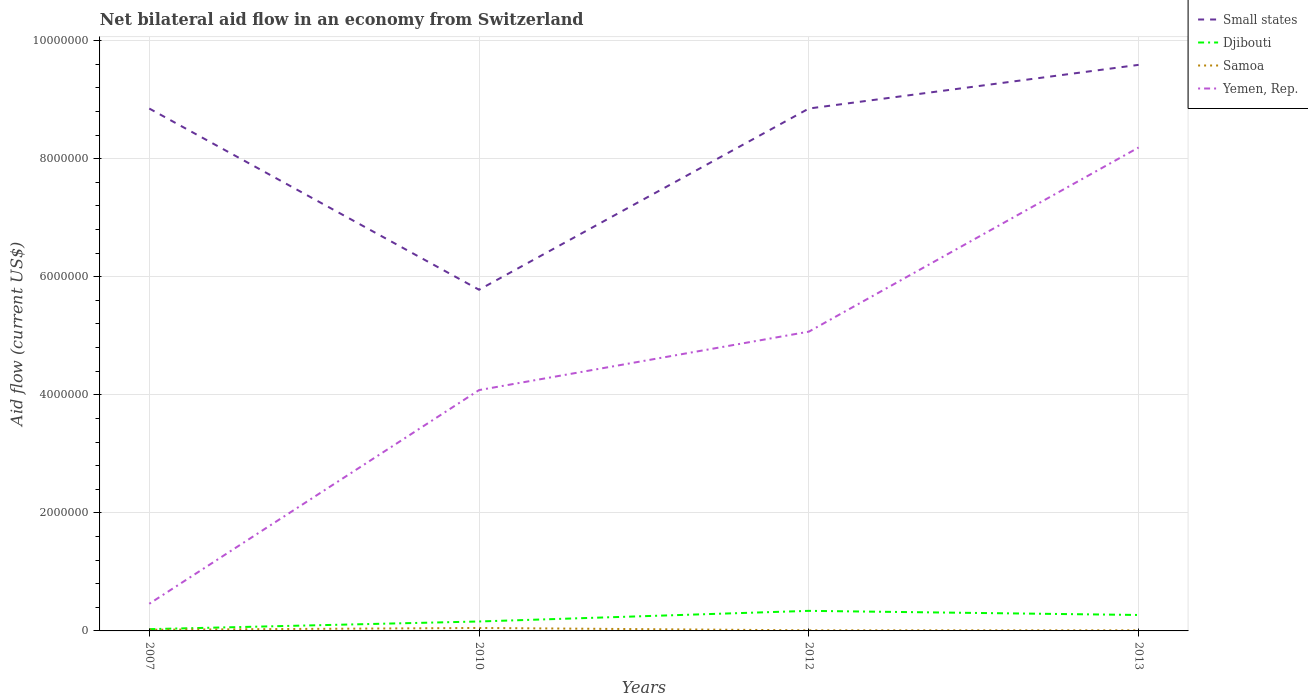How many different coloured lines are there?
Your response must be concise. 4. Is the number of lines equal to the number of legend labels?
Offer a very short reply. Yes. Across all years, what is the maximum net bilateral aid flow in Samoa?
Make the answer very short. 10000. What is the total net bilateral aid flow in Yemen, Rep. in the graph?
Provide a short and direct response. -9.90e+05. What is the difference between the highest and the second highest net bilateral aid flow in Samoa?
Offer a very short reply. 4.00e+04. Is the net bilateral aid flow in Samoa strictly greater than the net bilateral aid flow in Yemen, Rep. over the years?
Offer a terse response. Yes. How many lines are there?
Your answer should be compact. 4. How many years are there in the graph?
Provide a short and direct response. 4. Are the values on the major ticks of Y-axis written in scientific E-notation?
Offer a terse response. No. Does the graph contain grids?
Provide a succinct answer. Yes. Where does the legend appear in the graph?
Give a very brief answer. Top right. What is the title of the graph?
Your response must be concise. Net bilateral aid flow in an economy from Switzerland. What is the label or title of the X-axis?
Keep it short and to the point. Years. What is the Aid flow (current US$) in Small states in 2007?
Offer a very short reply. 8.85e+06. What is the Aid flow (current US$) in Samoa in 2007?
Your response must be concise. 2.00e+04. What is the Aid flow (current US$) of Small states in 2010?
Your response must be concise. 5.78e+06. What is the Aid flow (current US$) of Samoa in 2010?
Offer a terse response. 5.00e+04. What is the Aid flow (current US$) of Yemen, Rep. in 2010?
Provide a short and direct response. 4.08e+06. What is the Aid flow (current US$) in Small states in 2012?
Give a very brief answer. 8.85e+06. What is the Aid flow (current US$) of Djibouti in 2012?
Offer a terse response. 3.40e+05. What is the Aid flow (current US$) of Yemen, Rep. in 2012?
Keep it short and to the point. 5.07e+06. What is the Aid flow (current US$) in Small states in 2013?
Make the answer very short. 9.59e+06. What is the Aid flow (current US$) of Samoa in 2013?
Your answer should be very brief. 10000. What is the Aid flow (current US$) in Yemen, Rep. in 2013?
Keep it short and to the point. 8.19e+06. Across all years, what is the maximum Aid flow (current US$) of Small states?
Ensure brevity in your answer.  9.59e+06. Across all years, what is the maximum Aid flow (current US$) in Samoa?
Provide a short and direct response. 5.00e+04. Across all years, what is the maximum Aid flow (current US$) of Yemen, Rep.?
Make the answer very short. 8.19e+06. Across all years, what is the minimum Aid flow (current US$) in Small states?
Give a very brief answer. 5.78e+06. Across all years, what is the minimum Aid flow (current US$) of Samoa?
Offer a very short reply. 10000. What is the total Aid flow (current US$) in Small states in the graph?
Your answer should be compact. 3.31e+07. What is the total Aid flow (current US$) in Djibouti in the graph?
Your response must be concise. 8.00e+05. What is the total Aid flow (current US$) in Samoa in the graph?
Make the answer very short. 9.00e+04. What is the total Aid flow (current US$) of Yemen, Rep. in the graph?
Ensure brevity in your answer.  1.78e+07. What is the difference between the Aid flow (current US$) in Small states in 2007 and that in 2010?
Offer a terse response. 3.07e+06. What is the difference between the Aid flow (current US$) of Samoa in 2007 and that in 2010?
Ensure brevity in your answer.  -3.00e+04. What is the difference between the Aid flow (current US$) in Yemen, Rep. in 2007 and that in 2010?
Provide a succinct answer. -3.62e+06. What is the difference between the Aid flow (current US$) of Djibouti in 2007 and that in 2012?
Offer a very short reply. -3.10e+05. What is the difference between the Aid flow (current US$) of Samoa in 2007 and that in 2012?
Give a very brief answer. 10000. What is the difference between the Aid flow (current US$) in Yemen, Rep. in 2007 and that in 2012?
Keep it short and to the point. -4.61e+06. What is the difference between the Aid flow (current US$) in Small states in 2007 and that in 2013?
Make the answer very short. -7.40e+05. What is the difference between the Aid flow (current US$) of Djibouti in 2007 and that in 2013?
Keep it short and to the point. -2.40e+05. What is the difference between the Aid flow (current US$) of Samoa in 2007 and that in 2013?
Ensure brevity in your answer.  10000. What is the difference between the Aid flow (current US$) in Yemen, Rep. in 2007 and that in 2013?
Provide a short and direct response. -7.73e+06. What is the difference between the Aid flow (current US$) in Small states in 2010 and that in 2012?
Give a very brief answer. -3.07e+06. What is the difference between the Aid flow (current US$) in Djibouti in 2010 and that in 2012?
Your response must be concise. -1.80e+05. What is the difference between the Aid flow (current US$) of Yemen, Rep. in 2010 and that in 2012?
Make the answer very short. -9.90e+05. What is the difference between the Aid flow (current US$) in Small states in 2010 and that in 2013?
Your response must be concise. -3.81e+06. What is the difference between the Aid flow (current US$) of Yemen, Rep. in 2010 and that in 2013?
Ensure brevity in your answer.  -4.11e+06. What is the difference between the Aid flow (current US$) of Small states in 2012 and that in 2013?
Provide a short and direct response. -7.40e+05. What is the difference between the Aid flow (current US$) of Djibouti in 2012 and that in 2013?
Provide a short and direct response. 7.00e+04. What is the difference between the Aid flow (current US$) in Yemen, Rep. in 2012 and that in 2013?
Offer a terse response. -3.12e+06. What is the difference between the Aid flow (current US$) of Small states in 2007 and the Aid flow (current US$) of Djibouti in 2010?
Your answer should be very brief. 8.69e+06. What is the difference between the Aid flow (current US$) in Small states in 2007 and the Aid flow (current US$) in Samoa in 2010?
Provide a succinct answer. 8.80e+06. What is the difference between the Aid flow (current US$) of Small states in 2007 and the Aid flow (current US$) of Yemen, Rep. in 2010?
Provide a succinct answer. 4.77e+06. What is the difference between the Aid flow (current US$) in Djibouti in 2007 and the Aid flow (current US$) in Samoa in 2010?
Ensure brevity in your answer.  -2.00e+04. What is the difference between the Aid flow (current US$) of Djibouti in 2007 and the Aid flow (current US$) of Yemen, Rep. in 2010?
Make the answer very short. -4.05e+06. What is the difference between the Aid flow (current US$) of Samoa in 2007 and the Aid flow (current US$) of Yemen, Rep. in 2010?
Give a very brief answer. -4.06e+06. What is the difference between the Aid flow (current US$) of Small states in 2007 and the Aid flow (current US$) of Djibouti in 2012?
Your answer should be very brief. 8.51e+06. What is the difference between the Aid flow (current US$) of Small states in 2007 and the Aid flow (current US$) of Samoa in 2012?
Provide a short and direct response. 8.84e+06. What is the difference between the Aid flow (current US$) of Small states in 2007 and the Aid flow (current US$) of Yemen, Rep. in 2012?
Your answer should be compact. 3.78e+06. What is the difference between the Aid flow (current US$) in Djibouti in 2007 and the Aid flow (current US$) in Yemen, Rep. in 2012?
Your answer should be compact. -5.04e+06. What is the difference between the Aid flow (current US$) of Samoa in 2007 and the Aid flow (current US$) of Yemen, Rep. in 2012?
Your answer should be compact. -5.05e+06. What is the difference between the Aid flow (current US$) of Small states in 2007 and the Aid flow (current US$) of Djibouti in 2013?
Offer a terse response. 8.58e+06. What is the difference between the Aid flow (current US$) of Small states in 2007 and the Aid flow (current US$) of Samoa in 2013?
Ensure brevity in your answer.  8.84e+06. What is the difference between the Aid flow (current US$) of Small states in 2007 and the Aid flow (current US$) of Yemen, Rep. in 2013?
Your answer should be compact. 6.60e+05. What is the difference between the Aid flow (current US$) of Djibouti in 2007 and the Aid flow (current US$) of Samoa in 2013?
Offer a very short reply. 2.00e+04. What is the difference between the Aid flow (current US$) of Djibouti in 2007 and the Aid flow (current US$) of Yemen, Rep. in 2013?
Offer a very short reply. -8.16e+06. What is the difference between the Aid flow (current US$) in Samoa in 2007 and the Aid flow (current US$) in Yemen, Rep. in 2013?
Provide a short and direct response. -8.17e+06. What is the difference between the Aid flow (current US$) of Small states in 2010 and the Aid flow (current US$) of Djibouti in 2012?
Offer a terse response. 5.44e+06. What is the difference between the Aid flow (current US$) in Small states in 2010 and the Aid flow (current US$) in Samoa in 2012?
Offer a very short reply. 5.77e+06. What is the difference between the Aid flow (current US$) in Small states in 2010 and the Aid flow (current US$) in Yemen, Rep. in 2012?
Offer a terse response. 7.10e+05. What is the difference between the Aid flow (current US$) in Djibouti in 2010 and the Aid flow (current US$) in Yemen, Rep. in 2012?
Keep it short and to the point. -4.91e+06. What is the difference between the Aid flow (current US$) in Samoa in 2010 and the Aid flow (current US$) in Yemen, Rep. in 2012?
Give a very brief answer. -5.02e+06. What is the difference between the Aid flow (current US$) in Small states in 2010 and the Aid flow (current US$) in Djibouti in 2013?
Your answer should be compact. 5.51e+06. What is the difference between the Aid flow (current US$) in Small states in 2010 and the Aid flow (current US$) in Samoa in 2013?
Your answer should be compact. 5.77e+06. What is the difference between the Aid flow (current US$) in Small states in 2010 and the Aid flow (current US$) in Yemen, Rep. in 2013?
Keep it short and to the point. -2.41e+06. What is the difference between the Aid flow (current US$) of Djibouti in 2010 and the Aid flow (current US$) of Yemen, Rep. in 2013?
Offer a terse response. -8.03e+06. What is the difference between the Aid flow (current US$) of Samoa in 2010 and the Aid flow (current US$) of Yemen, Rep. in 2013?
Make the answer very short. -8.14e+06. What is the difference between the Aid flow (current US$) of Small states in 2012 and the Aid flow (current US$) of Djibouti in 2013?
Make the answer very short. 8.58e+06. What is the difference between the Aid flow (current US$) of Small states in 2012 and the Aid flow (current US$) of Samoa in 2013?
Give a very brief answer. 8.84e+06. What is the difference between the Aid flow (current US$) of Small states in 2012 and the Aid flow (current US$) of Yemen, Rep. in 2013?
Your answer should be very brief. 6.60e+05. What is the difference between the Aid flow (current US$) in Djibouti in 2012 and the Aid flow (current US$) in Samoa in 2013?
Keep it short and to the point. 3.30e+05. What is the difference between the Aid flow (current US$) of Djibouti in 2012 and the Aid flow (current US$) of Yemen, Rep. in 2013?
Ensure brevity in your answer.  -7.85e+06. What is the difference between the Aid flow (current US$) in Samoa in 2012 and the Aid flow (current US$) in Yemen, Rep. in 2013?
Provide a short and direct response. -8.18e+06. What is the average Aid flow (current US$) of Small states per year?
Keep it short and to the point. 8.27e+06. What is the average Aid flow (current US$) of Samoa per year?
Your response must be concise. 2.25e+04. What is the average Aid flow (current US$) in Yemen, Rep. per year?
Your answer should be very brief. 4.45e+06. In the year 2007, what is the difference between the Aid flow (current US$) of Small states and Aid flow (current US$) of Djibouti?
Give a very brief answer. 8.82e+06. In the year 2007, what is the difference between the Aid flow (current US$) in Small states and Aid flow (current US$) in Samoa?
Provide a short and direct response. 8.83e+06. In the year 2007, what is the difference between the Aid flow (current US$) of Small states and Aid flow (current US$) of Yemen, Rep.?
Your response must be concise. 8.39e+06. In the year 2007, what is the difference between the Aid flow (current US$) in Djibouti and Aid flow (current US$) in Samoa?
Provide a short and direct response. 10000. In the year 2007, what is the difference between the Aid flow (current US$) of Djibouti and Aid flow (current US$) of Yemen, Rep.?
Keep it short and to the point. -4.30e+05. In the year 2007, what is the difference between the Aid flow (current US$) in Samoa and Aid flow (current US$) in Yemen, Rep.?
Make the answer very short. -4.40e+05. In the year 2010, what is the difference between the Aid flow (current US$) of Small states and Aid flow (current US$) of Djibouti?
Provide a short and direct response. 5.62e+06. In the year 2010, what is the difference between the Aid flow (current US$) of Small states and Aid flow (current US$) of Samoa?
Keep it short and to the point. 5.73e+06. In the year 2010, what is the difference between the Aid flow (current US$) in Small states and Aid flow (current US$) in Yemen, Rep.?
Provide a succinct answer. 1.70e+06. In the year 2010, what is the difference between the Aid flow (current US$) of Djibouti and Aid flow (current US$) of Samoa?
Offer a very short reply. 1.10e+05. In the year 2010, what is the difference between the Aid flow (current US$) of Djibouti and Aid flow (current US$) of Yemen, Rep.?
Keep it short and to the point. -3.92e+06. In the year 2010, what is the difference between the Aid flow (current US$) of Samoa and Aid flow (current US$) of Yemen, Rep.?
Make the answer very short. -4.03e+06. In the year 2012, what is the difference between the Aid flow (current US$) of Small states and Aid flow (current US$) of Djibouti?
Keep it short and to the point. 8.51e+06. In the year 2012, what is the difference between the Aid flow (current US$) in Small states and Aid flow (current US$) in Samoa?
Your answer should be very brief. 8.84e+06. In the year 2012, what is the difference between the Aid flow (current US$) in Small states and Aid flow (current US$) in Yemen, Rep.?
Your answer should be very brief. 3.78e+06. In the year 2012, what is the difference between the Aid flow (current US$) of Djibouti and Aid flow (current US$) of Yemen, Rep.?
Your answer should be compact. -4.73e+06. In the year 2012, what is the difference between the Aid flow (current US$) of Samoa and Aid flow (current US$) of Yemen, Rep.?
Your answer should be very brief. -5.06e+06. In the year 2013, what is the difference between the Aid flow (current US$) in Small states and Aid flow (current US$) in Djibouti?
Offer a terse response. 9.32e+06. In the year 2013, what is the difference between the Aid flow (current US$) of Small states and Aid flow (current US$) of Samoa?
Provide a succinct answer. 9.58e+06. In the year 2013, what is the difference between the Aid flow (current US$) of Small states and Aid flow (current US$) of Yemen, Rep.?
Ensure brevity in your answer.  1.40e+06. In the year 2013, what is the difference between the Aid flow (current US$) in Djibouti and Aid flow (current US$) in Samoa?
Your response must be concise. 2.60e+05. In the year 2013, what is the difference between the Aid flow (current US$) in Djibouti and Aid flow (current US$) in Yemen, Rep.?
Offer a terse response. -7.92e+06. In the year 2013, what is the difference between the Aid flow (current US$) of Samoa and Aid flow (current US$) of Yemen, Rep.?
Your answer should be very brief. -8.18e+06. What is the ratio of the Aid flow (current US$) in Small states in 2007 to that in 2010?
Give a very brief answer. 1.53. What is the ratio of the Aid flow (current US$) in Djibouti in 2007 to that in 2010?
Your answer should be compact. 0.19. What is the ratio of the Aid flow (current US$) of Samoa in 2007 to that in 2010?
Ensure brevity in your answer.  0.4. What is the ratio of the Aid flow (current US$) of Yemen, Rep. in 2007 to that in 2010?
Your answer should be compact. 0.11. What is the ratio of the Aid flow (current US$) in Djibouti in 2007 to that in 2012?
Make the answer very short. 0.09. What is the ratio of the Aid flow (current US$) of Samoa in 2007 to that in 2012?
Your answer should be compact. 2. What is the ratio of the Aid flow (current US$) in Yemen, Rep. in 2007 to that in 2012?
Ensure brevity in your answer.  0.09. What is the ratio of the Aid flow (current US$) in Small states in 2007 to that in 2013?
Provide a short and direct response. 0.92. What is the ratio of the Aid flow (current US$) in Djibouti in 2007 to that in 2013?
Your answer should be compact. 0.11. What is the ratio of the Aid flow (current US$) of Yemen, Rep. in 2007 to that in 2013?
Provide a succinct answer. 0.06. What is the ratio of the Aid flow (current US$) of Small states in 2010 to that in 2012?
Offer a very short reply. 0.65. What is the ratio of the Aid flow (current US$) in Djibouti in 2010 to that in 2012?
Your answer should be very brief. 0.47. What is the ratio of the Aid flow (current US$) of Yemen, Rep. in 2010 to that in 2012?
Provide a succinct answer. 0.8. What is the ratio of the Aid flow (current US$) of Small states in 2010 to that in 2013?
Give a very brief answer. 0.6. What is the ratio of the Aid flow (current US$) in Djibouti in 2010 to that in 2013?
Your answer should be compact. 0.59. What is the ratio of the Aid flow (current US$) in Samoa in 2010 to that in 2013?
Provide a succinct answer. 5. What is the ratio of the Aid flow (current US$) of Yemen, Rep. in 2010 to that in 2013?
Provide a short and direct response. 0.5. What is the ratio of the Aid flow (current US$) in Small states in 2012 to that in 2013?
Your answer should be very brief. 0.92. What is the ratio of the Aid flow (current US$) in Djibouti in 2012 to that in 2013?
Keep it short and to the point. 1.26. What is the ratio of the Aid flow (current US$) of Yemen, Rep. in 2012 to that in 2013?
Give a very brief answer. 0.62. What is the difference between the highest and the second highest Aid flow (current US$) of Small states?
Your answer should be compact. 7.40e+05. What is the difference between the highest and the second highest Aid flow (current US$) of Samoa?
Offer a very short reply. 3.00e+04. What is the difference between the highest and the second highest Aid flow (current US$) of Yemen, Rep.?
Ensure brevity in your answer.  3.12e+06. What is the difference between the highest and the lowest Aid flow (current US$) in Small states?
Make the answer very short. 3.81e+06. What is the difference between the highest and the lowest Aid flow (current US$) of Yemen, Rep.?
Make the answer very short. 7.73e+06. 